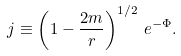<formula> <loc_0><loc_0><loc_500><loc_500>j \equiv \left ( 1 - \frac { 2 m } { r } \right ) ^ { 1 / 2 } \, e ^ { - \Phi } .</formula> 